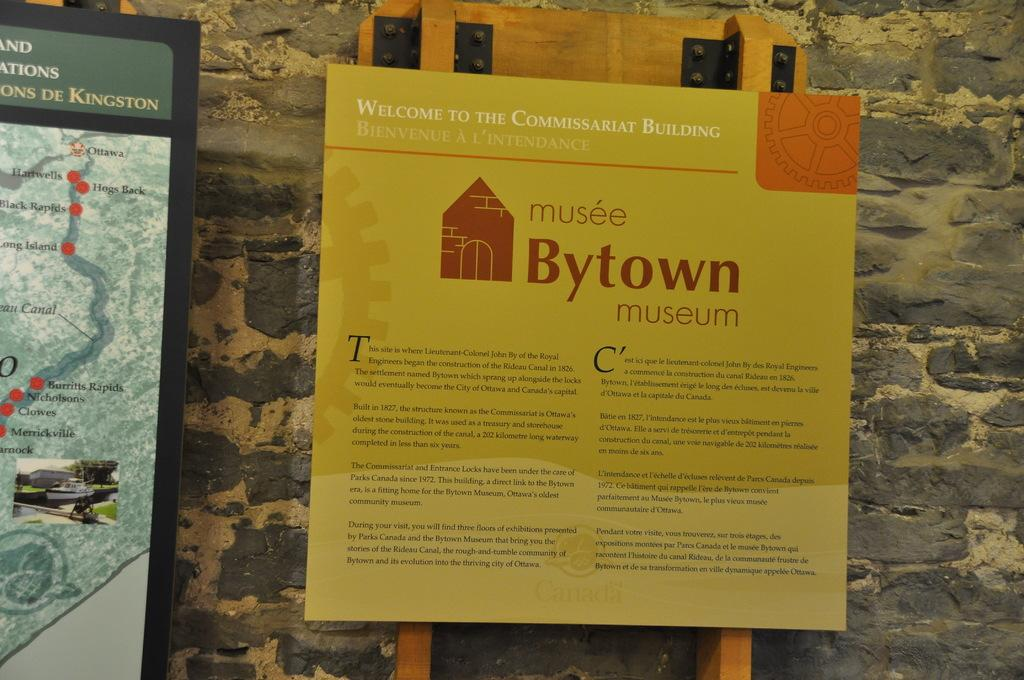<image>
Present a compact description of the photo's key features. A flyer for Bytown museum is shown on a wall. 